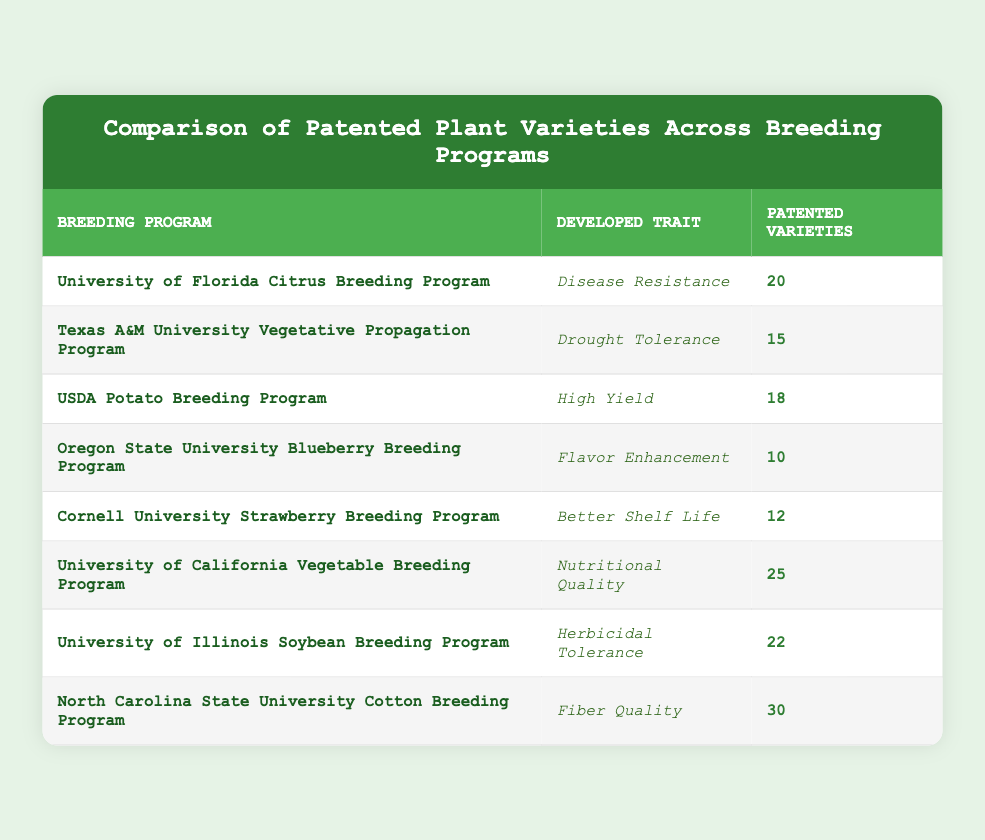What is the total number of patented varieties for the North Carolina State University Cotton Breeding Program? The table shows that the North Carolina State University Cotton Breeding Program has patented 30 varieties. I can find this directly in the table under the "Patented Varieties" column for this specific program.
Answer: 30 Which breeding program has developed the trait of Nutritional Quality? Looking at the table, the University of California Vegetable Breeding Program is associated with the trait of Nutritional Quality. I can confirm this by checking the relevant row.
Answer: University of California Vegetable Breeding Program What is the total number of patented varieties across all breeding programs? To find the total, I need to sum the values from the "Patented Varieties" column: 20 + 15 + 18 + 10 + 12 + 25 + 22 + 30 = 152. Therefore, the total number of patented varieties across all programs is 152.
Answer: 152 Is it true that the USDA Potato Breeding Program has more than 20 patented varieties? In the table, the USDA Potato Breeding Program shows 18 patented varieties. Since 18 is less than 20, the statement is false.
Answer: No Which program has the highest number of patented varieties and what is that number? By reviewing the table, I see that the North Carolina State University Cotton Breeding Program has the highest number of patented varieties at 30. This is the highest value listed in the "Patented Varieties" column.
Answer: 30 What is the difference in the number of patented varieties between the University of Florida Citrus Breeding Program and the Oregon State University Blueberry Breeding Program? The University of Florida Citrus Breeding Program has 20 patented varieties, while the Oregon State University Blueberry Breeding Program has 10. I can find the difference by subtracting: 20 - 10 = 10.
Answer: 10 Which trait has the fewest patented varieties and what breeding program is associated with it? Looking through the table, Flavor Enhancement stands out as it is associated with the Oregon State University Blueberry Breeding Program and has 10 patented varieties, which is the lowest in the list.
Answer: Flavor Enhancement; Oregon State University Blueberry Breeding Program How many breeding programs focus on traits related to quality (like Fiber Quality, Nutritional Quality, and Better Shelf Life)? Checking the table, I notice three programs that develop quality-related traits: University of California Vegetable Breeding Program (Nutritional Quality), Cornell University Strawberry Breeding Program (Better Shelf Life), and North Carolina State University Cotton Breeding Program (Fiber Quality). Hence, there are three programs that fit this criteria.
Answer: 3 